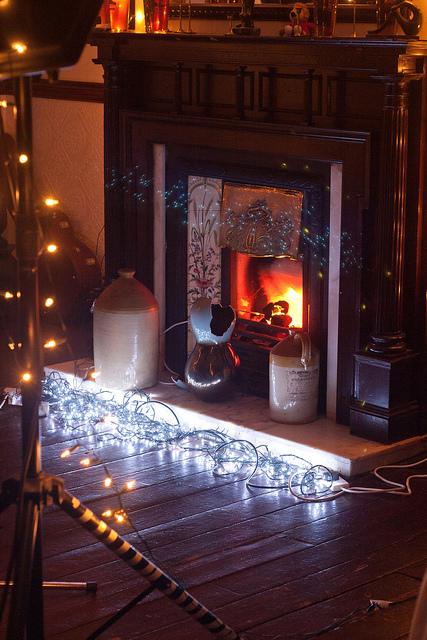What season is it?
Write a very short answer. Winter. How many light bulbs are there?
Give a very brief answer. 12. What is in front of the fireplace?
Write a very short answer. Jugs. 